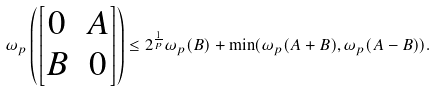Convert formula to latex. <formula><loc_0><loc_0><loc_500><loc_500>\omega _ { p } \left ( \begin{bmatrix} 0 & A \\ B & 0 \end{bmatrix} \right ) \leq 2 ^ { \frac { 1 } { p } } \omega _ { p } ( B ) + \min ( \omega _ { p } ( A + B ) , \omega _ { p } ( A - B ) ) .</formula> 